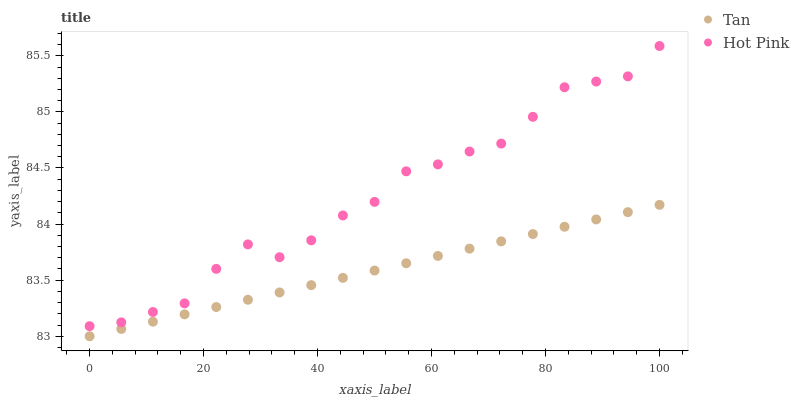Does Tan have the minimum area under the curve?
Answer yes or no. Yes. Does Hot Pink have the maximum area under the curve?
Answer yes or no. Yes. Does Hot Pink have the minimum area under the curve?
Answer yes or no. No. Is Tan the smoothest?
Answer yes or no. Yes. Is Hot Pink the roughest?
Answer yes or no. Yes. Is Hot Pink the smoothest?
Answer yes or no. No. Does Tan have the lowest value?
Answer yes or no. Yes. Does Hot Pink have the lowest value?
Answer yes or no. No. Does Hot Pink have the highest value?
Answer yes or no. Yes. Is Tan less than Hot Pink?
Answer yes or no. Yes. Is Hot Pink greater than Tan?
Answer yes or no. Yes. Does Tan intersect Hot Pink?
Answer yes or no. No. 